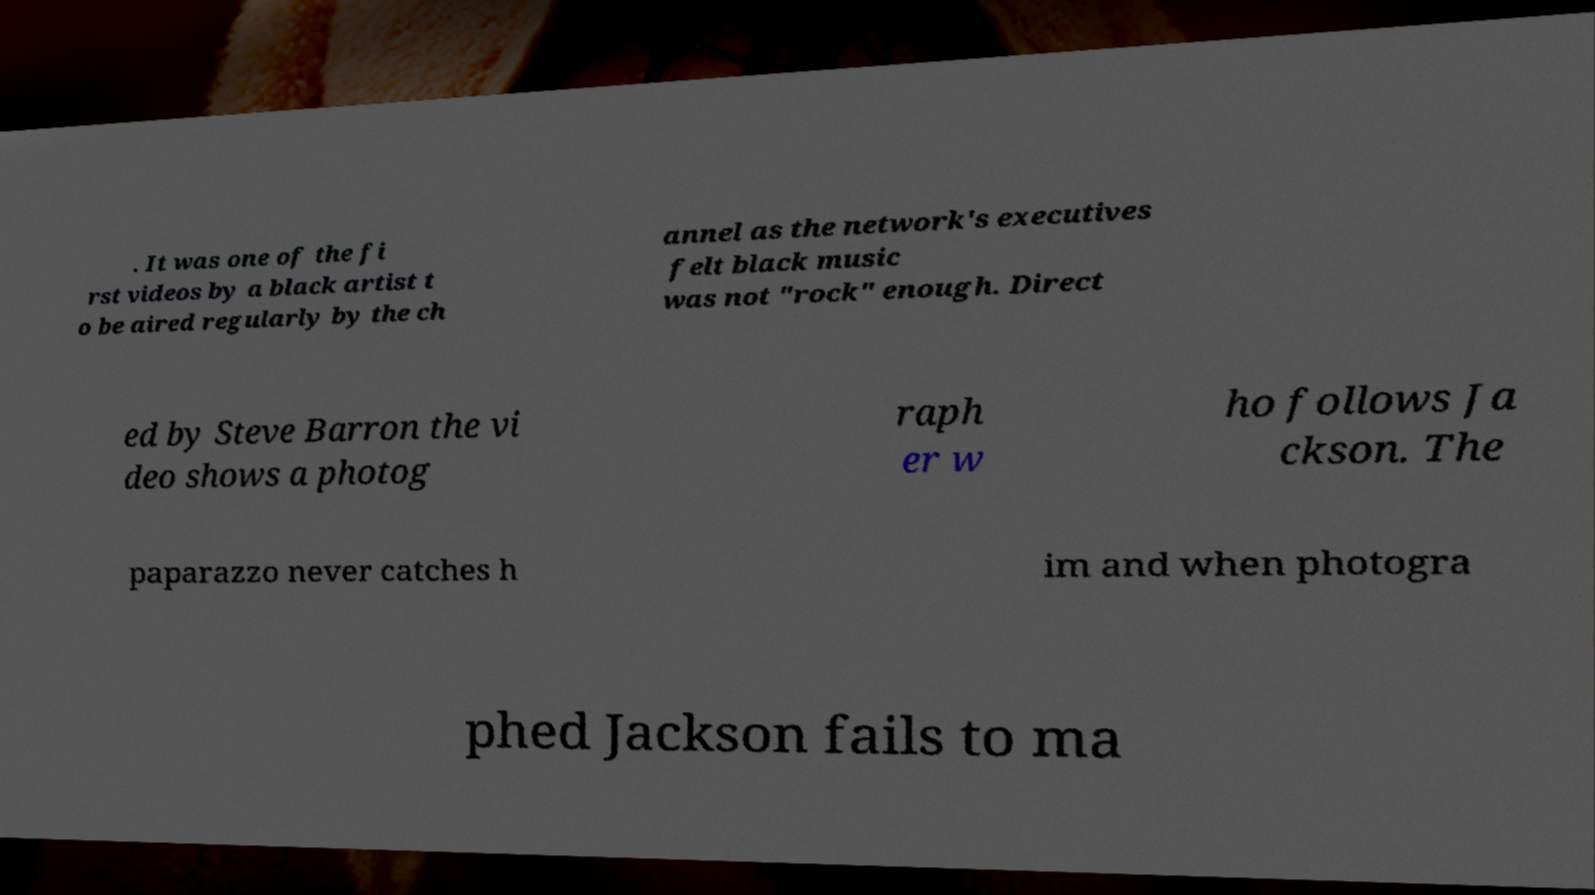Could you extract and type out the text from this image? . It was one of the fi rst videos by a black artist t o be aired regularly by the ch annel as the network's executives felt black music was not "rock" enough. Direct ed by Steve Barron the vi deo shows a photog raph er w ho follows Ja ckson. The paparazzo never catches h im and when photogra phed Jackson fails to ma 